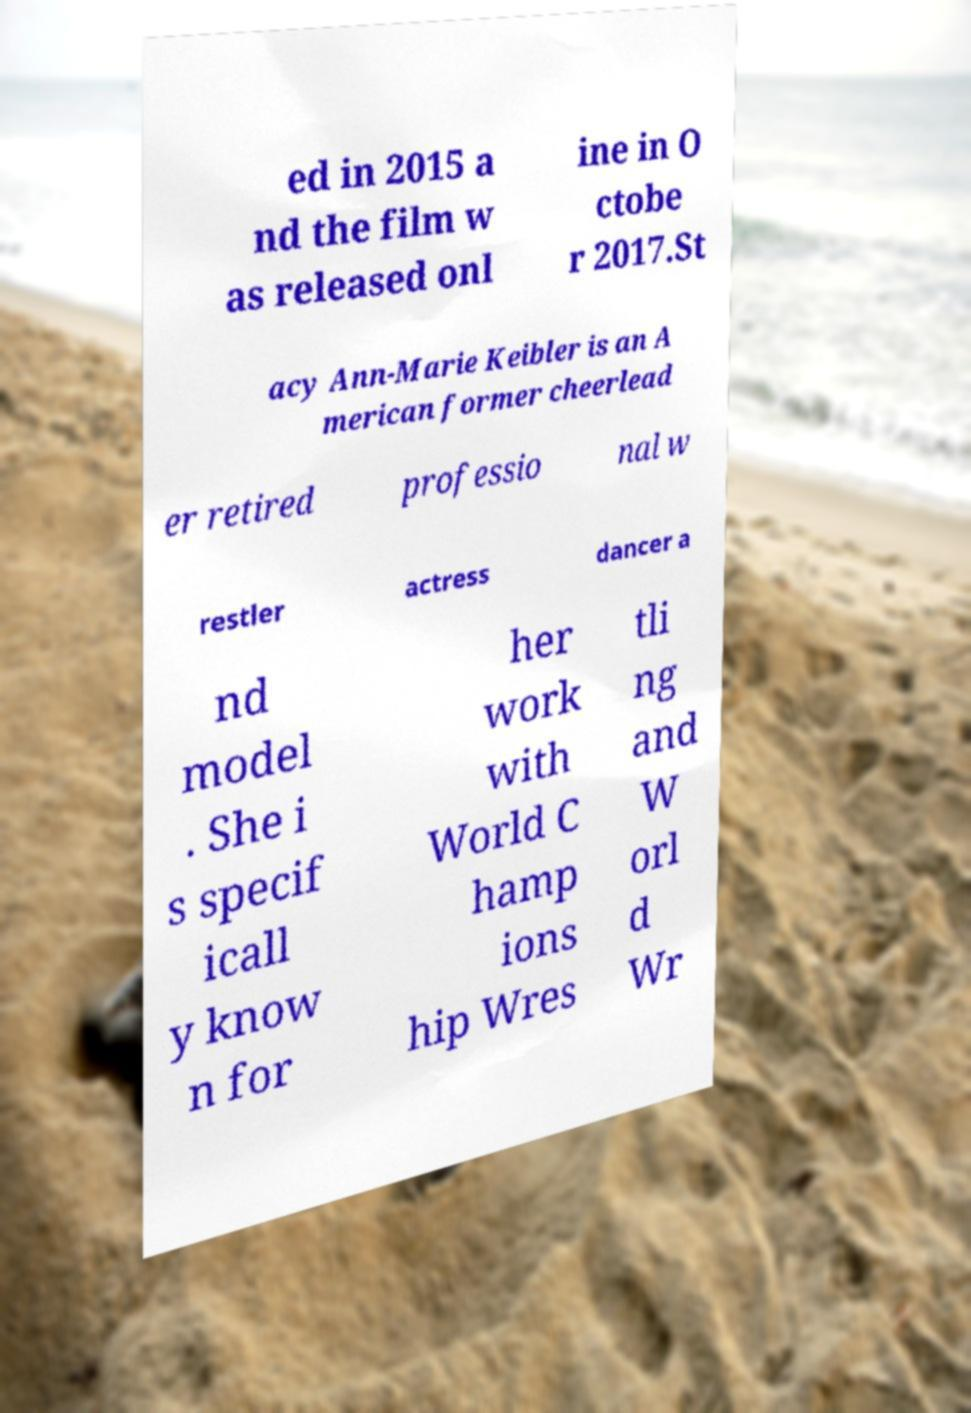Can you accurately transcribe the text from the provided image for me? ed in 2015 a nd the film w as released onl ine in O ctobe r 2017.St acy Ann-Marie Keibler is an A merican former cheerlead er retired professio nal w restler actress dancer a nd model . She i s specif icall y know n for her work with World C hamp ions hip Wres tli ng and W orl d Wr 